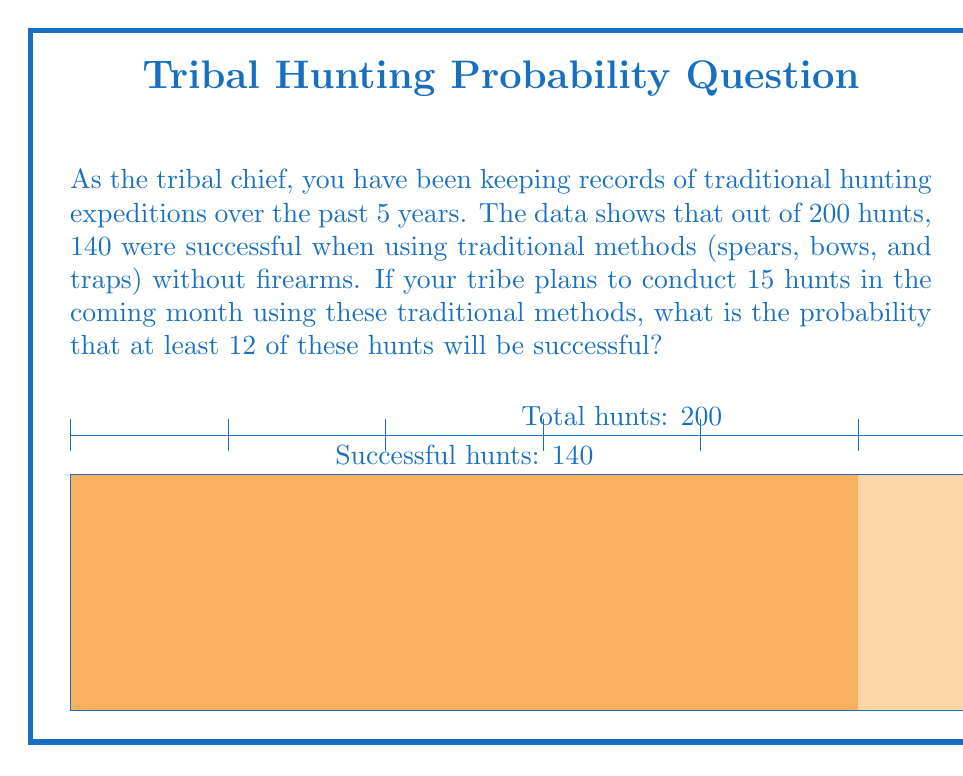What is the answer to this math problem? Let's approach this step-by-step:

1) First, we need to calculate the probability of a single hunt being successful based on the historical data:

   $p = \frac{\text{number of successful hunts}}{\text{total number of hunts}} = \frac{140}{200} = 0.7$

2) Now, we're looking at 15 hunts and want the probability of at least 12 being successful. This can be modeled as a binomial distribution.

3) The probability of exactly $k$ successes in $n$ trials is given by the binomial probability formula:

   $P(X = k) = \binom{n}{k} p^k (1-p)^{n-k}$

4) We want the probability of 12, 13, 14, or 15 successes out of 15 trials. So we need to sum these individual probabilities:

   $P(X \geq 12) = P(X = 12) + P(X = 13) + P(X = 14) + P(X = 15)$

5) Let's calculate each term:

   $P(X = 12) = \binom{15}{12} 0.7^{12} 0.3^3 \approx 0.1841$
   $P(X = 13) = \binom{15}{13} 0.7^{13} 0.3^2 \approx 0.1642$
   $P(X = 14) = \binom{15}{14} 0.7^{14} 0.3^1 \approx 0.0705$
   $P(X = 15) = \binom{15}{15} 0.7^{15} 0.3^0 \approx 0.0127$

6) Sum these probabilities:

   $P(X \geq 12) = 0.1841 + 0.1642 + 0.0705 + 0.0127 \approx 0.4315$

Therefore, the probability of at least 12 out of 15 hunts being successful is approximately 0.4315 or 43.15%.
Answer: 0.4315 